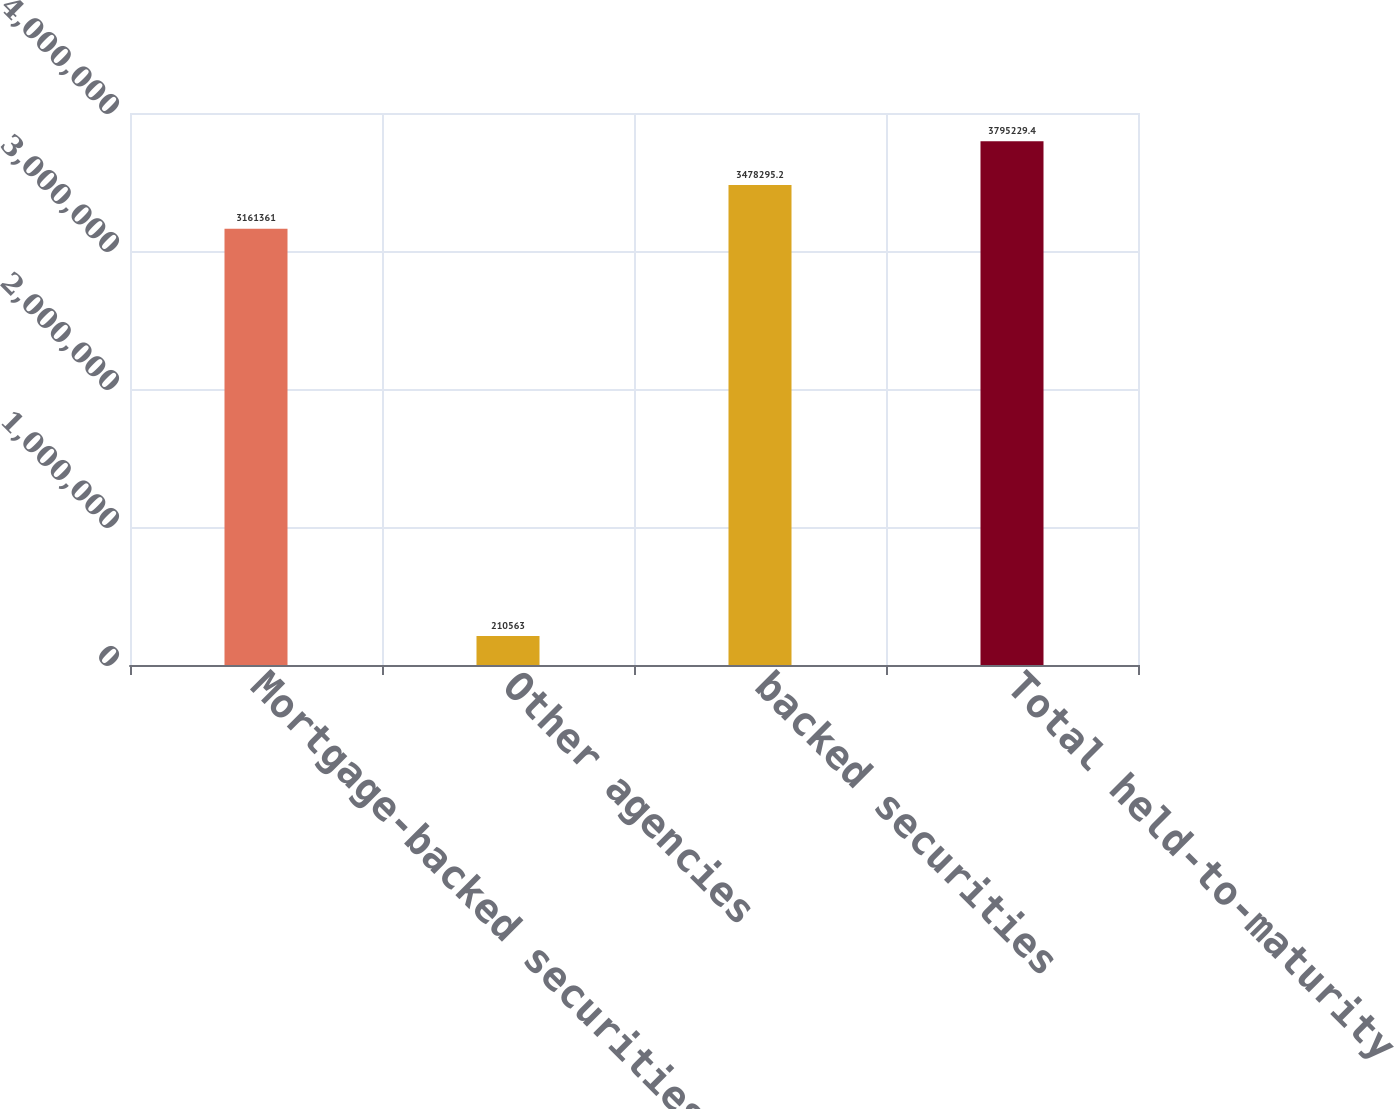Convert chart. <chart><loc_0><loc_0><loc_500><loc_500><bar_chart><fcel>Mortgage-backed securities<fcel>Other agencies<fcel>backed securities<fcel>Total held-to-maturity<nl><fcel>3.16136e+06<fcel>210563<fcel>3.4783e+06<fcel>3.79523e+06<nl></chart> 